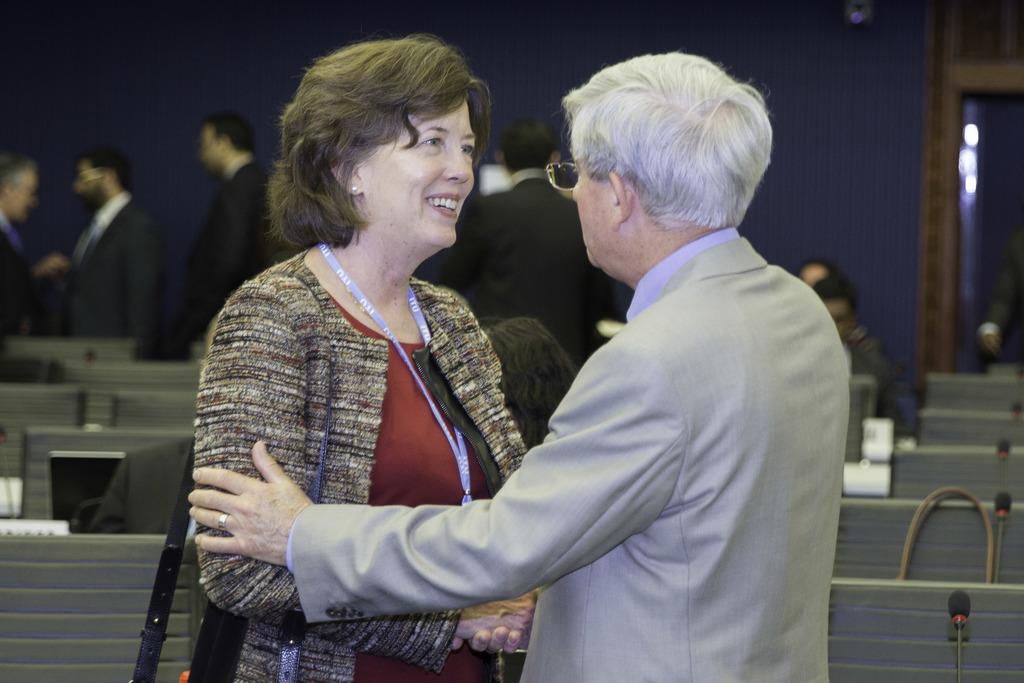What is the man doing in the image? The man is holding a woman in the image. What object can be seen on a table in the image? There is a laptop on a table in the image. What can be found on the right side of the image? There are mics on the right side of the image. What can be seen in the background of the image? There are people and lights visible in the background of the image. What type of dress is the man wearing in the image? The man is not wearing a dress in the image; he is wearing regular clothing. How many letters are visible on the laptop screen in the image? There is no information about the laptop screen or any letters visible on it in the image. 